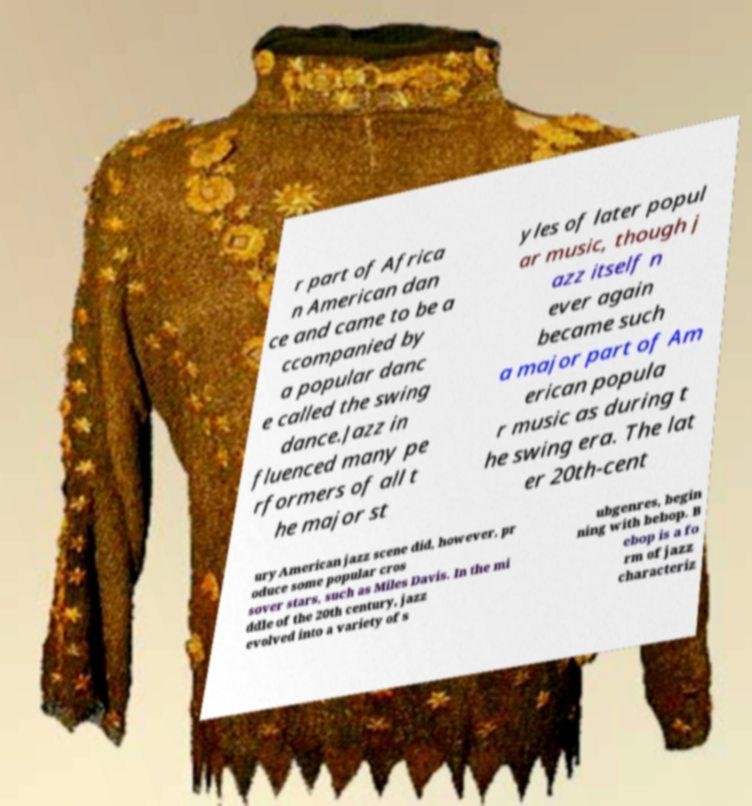Could you assist in decoding the text presented in this image and type it out clearly? r part of Africa n American dan ce and came to be a ccompanied by a popular danc e called the swing dance.Jazz in fluenced many pe rformers of all t he major st yles of later popul ar music, though j azz itself n ever again became such a major part of Am erican popula r music as during t he swing era. The lat er 20th-cent ury American jazz scene did, however, pr oduce some popular cros sover stars, such as Miles Davis. In the mi ddle of the 20th century, jazz evolved into a variety of s ubgenres, begin ning with bebop. B ebop is a fo rm of jazz characteriz 